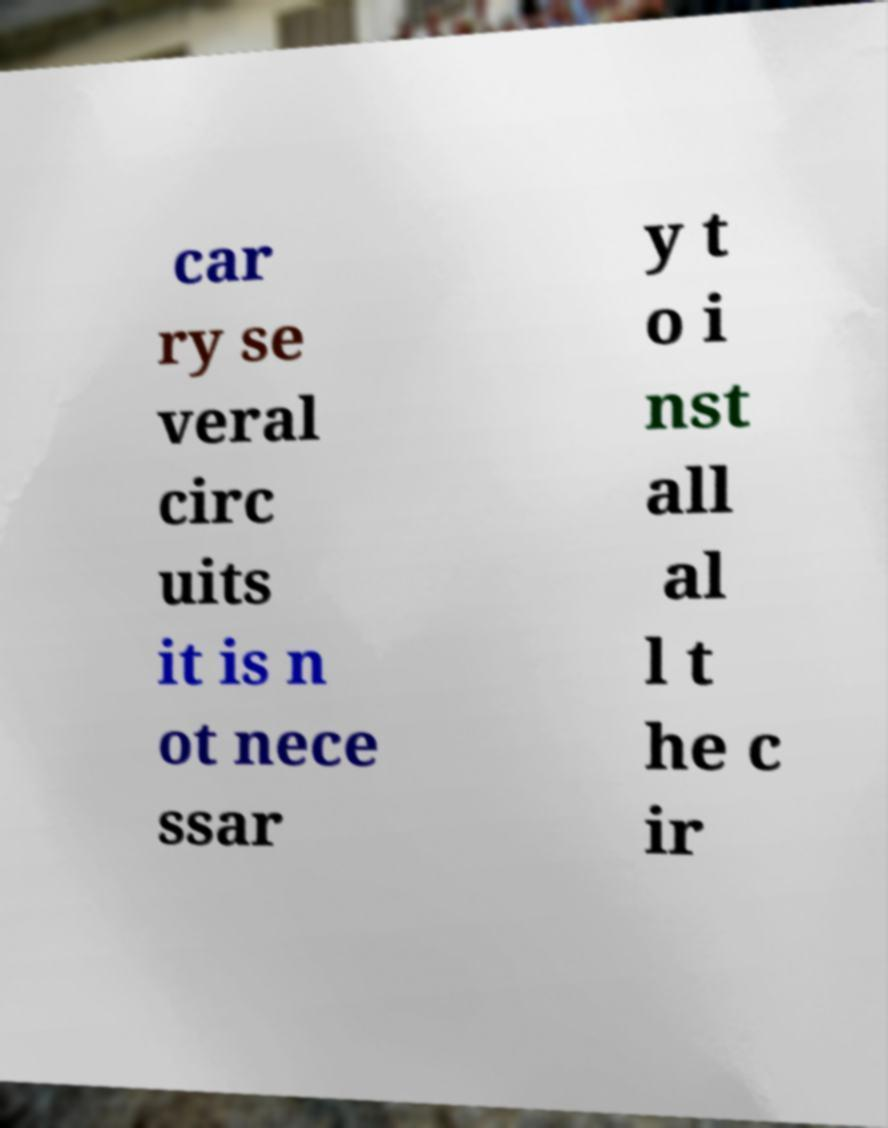There's text embedded in this image that I need extracted. Can you transcribe it verbatim? car ry se veral circ uits it is n ot nece ssar y t o i nst all al l t he c ir 